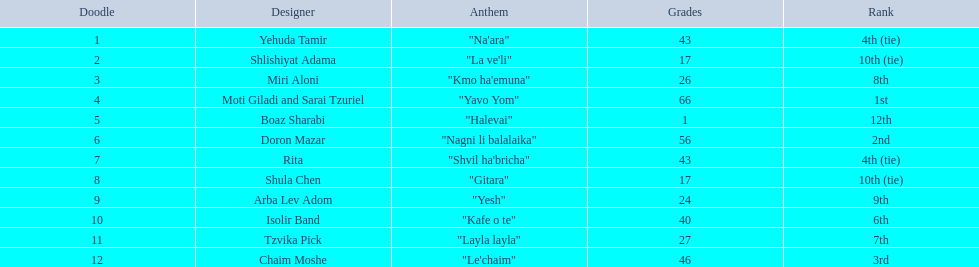What are the points in the competition? 43, 17, 26, 66, 1, 56, 43, 17, 24, 40, 27, 46. What is the lowest points? 1. What artist received these points? Boaz Sharabi. 